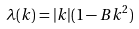<formula> <loc_0><loc_0><loc_500><loc_500>\lambda ( k ) = | k | ( 1 - B k ^ { 2 } )</formula> 